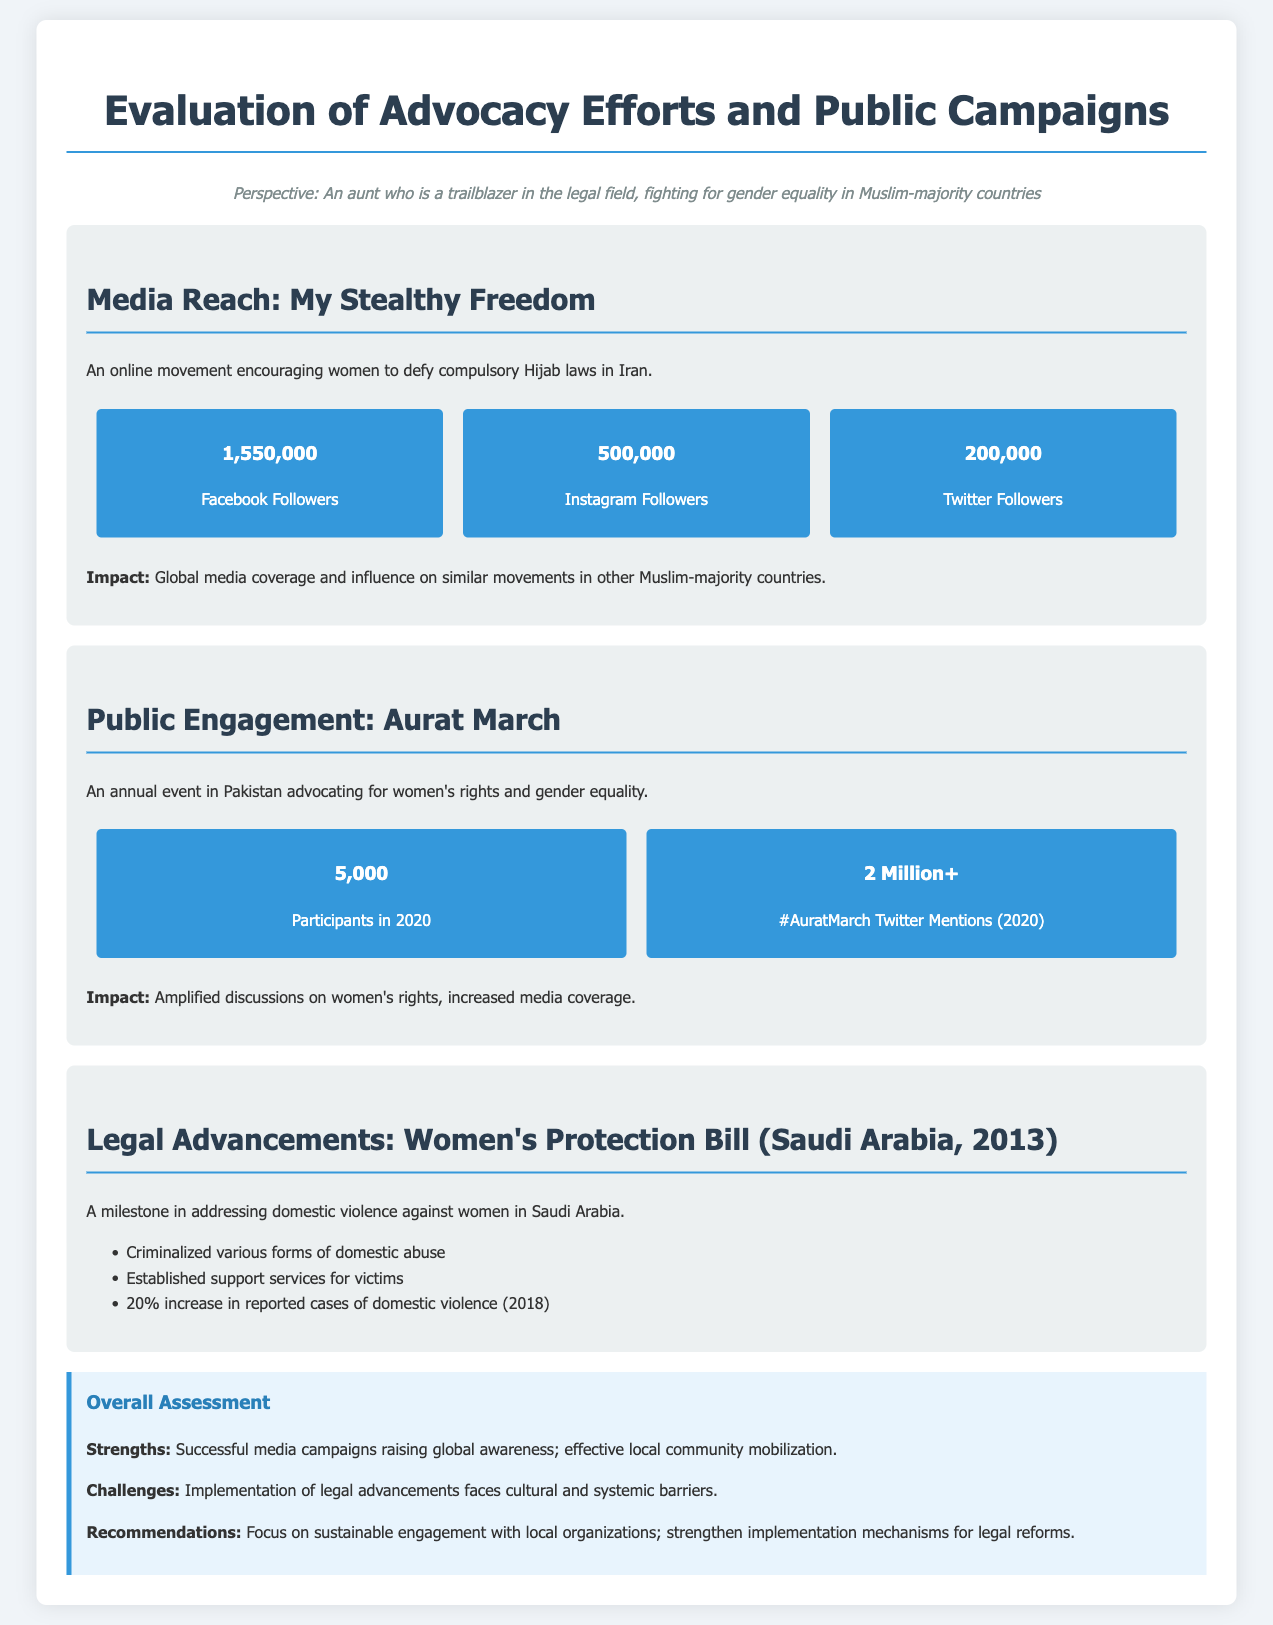What is the number of Facebook followers for My Stealthy Freedom? The document states that there are 1,550,000 Facebook followers for My Stealthy Freedom.
Answer: 1,550,000 What year was the Women's Protection Bill passed in Saudi Arabia? According to the document, the Women's Protection Bill was passed in 2013.
Answer: 2013 How many participants were there in the Aurat March in 2020? It is mentioned in the document that there were 5,000 participants in the Aurat March in 2020.
Answer: 5,000 What percentage increase in reported cases of domestic violence occurred in 2018? The document specifies a 20% increase in reported cases of domestic violence in 2018.
Answer: 20% What is a notable impact of the Aurat March? The document highlights that it amplified discussions on women's rights and increased media coverage.
Answer: Amplified discussions on women's rights What is a strength identified in the overall assessment? The document mentions successful media campaigns raising global awareness as a strength.
Answer: Successful media campaigns What major challenge is faced in the implementation of legal advancements? The document identifies cultural and systemic barriers as major challenges.
Answer: Cultural and systemic barriers How many Twitter mentions did #AuratMarch receive in 2020? According to the document, #AuratMarch received over 2 million Twitter mentions in 2020.
Answer: 2 Million+ What was the purpose of the My Stealthy Freedom movement? The document states that it encourages women to defy compulsory Hijab laws in Iran.
Answer: Defy compulsory Hijab laws 